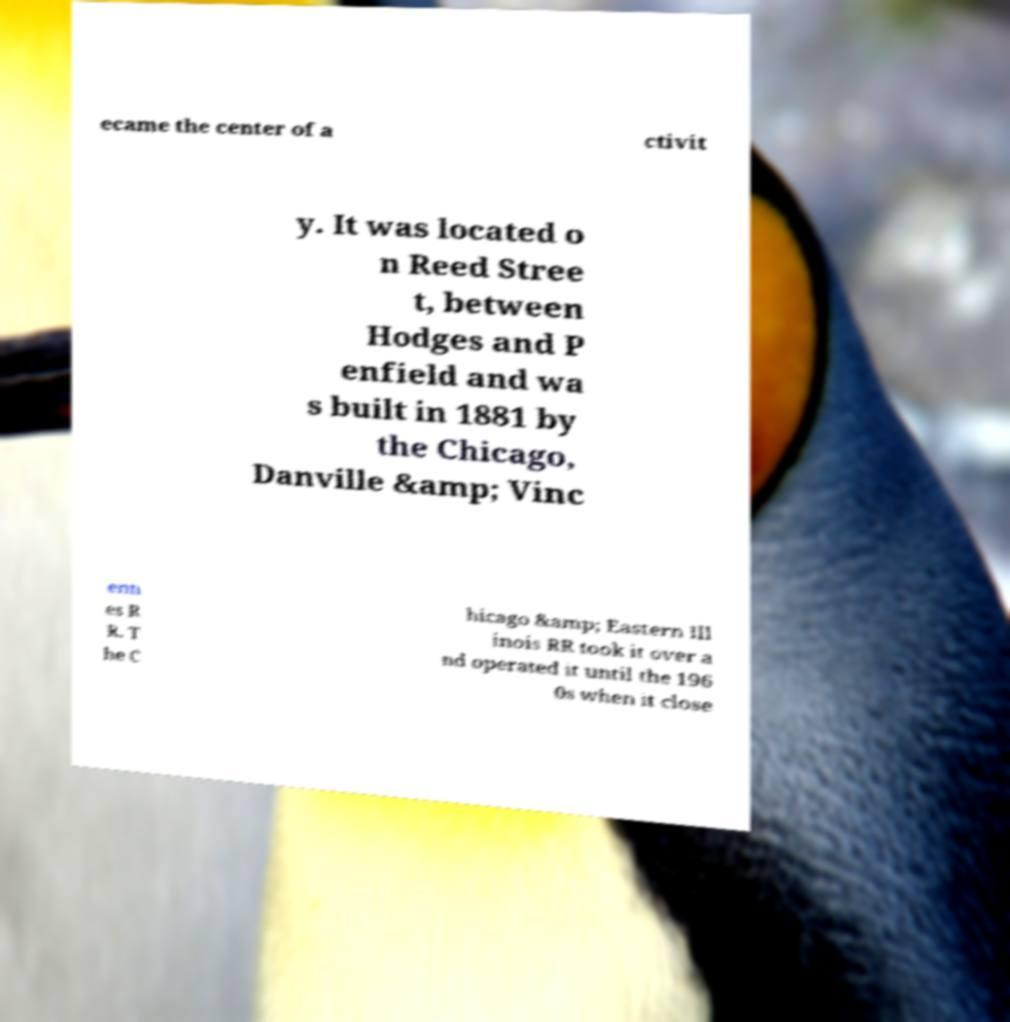Could you extract and type out the text from this image? ecame the center of a ctivit y. It was located o n Reed Stree t, between Hodges and P enfield and wa s built in 1881 by the Chicago, Danville &amp; Vinc enn es R R. T he C hicago &amp; Eastern Ill inois RR took it over a nd operated it until the 196 0s when it close 